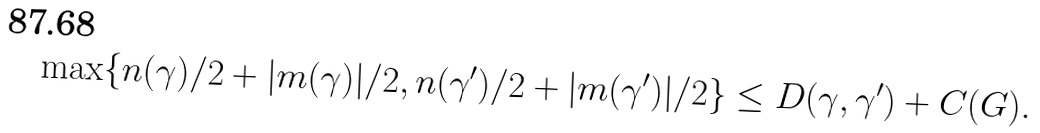Convert formula to latex. <formula><loc_0><loc_0><loc_500><loc_500>\max \{ n ( \gamma ) / 2 + | m ( \gamma ) | / 2 , n ( \gamma ^ { \prime } ) / 2 + | m ( \gamma ^ { \prime } ) | / 2 \} \leq D ( \gamma , \gamma ^ { \prime } ) + C ( G ) .</formula> 